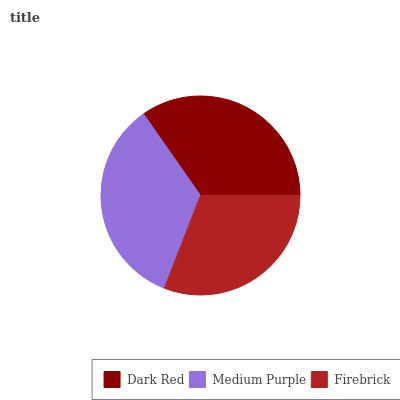Is Firebrick the minimum?
Answer yes or no. Yes. Is Dark Red the maximum?
Answer yes or no. Yes. Is Medium Purple the minimum?
Answer yes or no. No. Is Medium Purple the maximum?
Answer yes or no. No. Is Dark Red greater than Medium Purple?
Answer yes or no. Yes. Is Medium Purple less than Dark Red?
Answer yes or no. Yes. Is Medium Purple greater than Dark Red?
Answer yes or no. No. Is Dark Red less than Medium Purple?
Answer yes or no. No. Is Medium Purple the high median?
Answer yes or no. Yes. Is Medium Purple the low median?
Answer yes or no. Yes. Is Firebrick the high median?
Answer yes or no. No. Is Firebrick the low median?
Answer yes or no. No. 